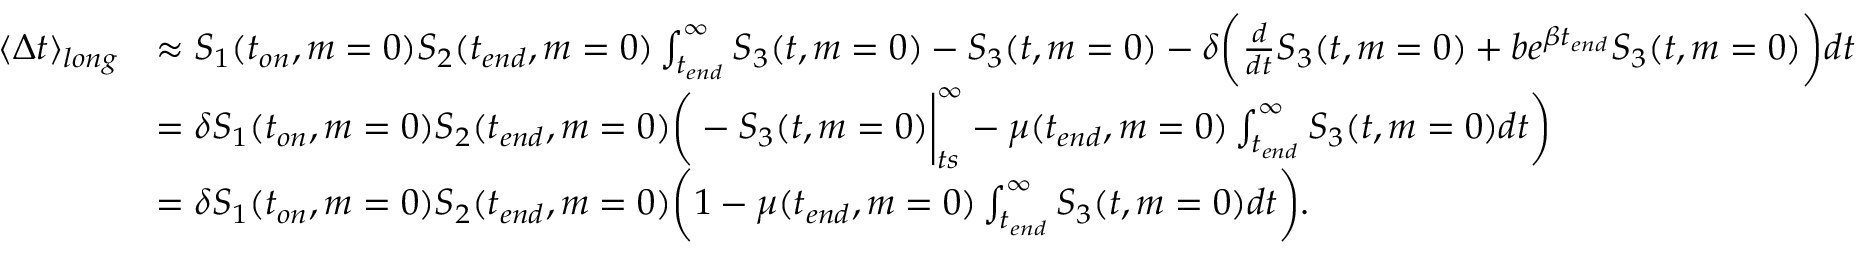<formula> <loc_0><loc_0><loc_500><loc_500>\begin{array} { r l } { \langle \Delta t \rangle _ { l o n g } } & { \approx S _ { 1 } ( t _ { o n } , m = 0 ) S _ { 2 } ( t _ { e n d } , m = 0 ) \int _ { t _ { e n d } } ^ { \infty } S _ { 3 } ( t , m = 0 ) - S _ { 3 } ( t , m = 0 ) - \delta \Big ( \frac { d } { d t } S _ { 3 } ( t , m = 0 ) + b e ^ { \beta t _ { e n d } } S _ { 3 } ( t , m = 0 ) \Big ) d t } \\ & { = \delta S _ { 1 } ( t _ { o n } , m = 0 ) S _ { 2 } ( t _ { e n d } , m = 0 ) \Big ( - S _ { 3 } ( t , m = 0 ) \Big | _ { t s } ^ { \infty } - \mu ( t _ { e n d } , m = 0 ) \int _ { t _ { e n d } } ^ { \infty } S _ { 3 } ( t , m = 0 ) d t \Big ) } \\ & { = \delta S _ { 1 } ( t _ { o n } , m = 0 ) S _ { 2 } ( t _ { e n d } , m = 0 ) \Big ( 1 - \mu ( t _ { e n d } , m = 0 ) \int _ { t _ { e n d } } ^ { \infty } S _ { 3 } ( t , m = 0 ) d t \Big ) . } \end{array}</formula> 